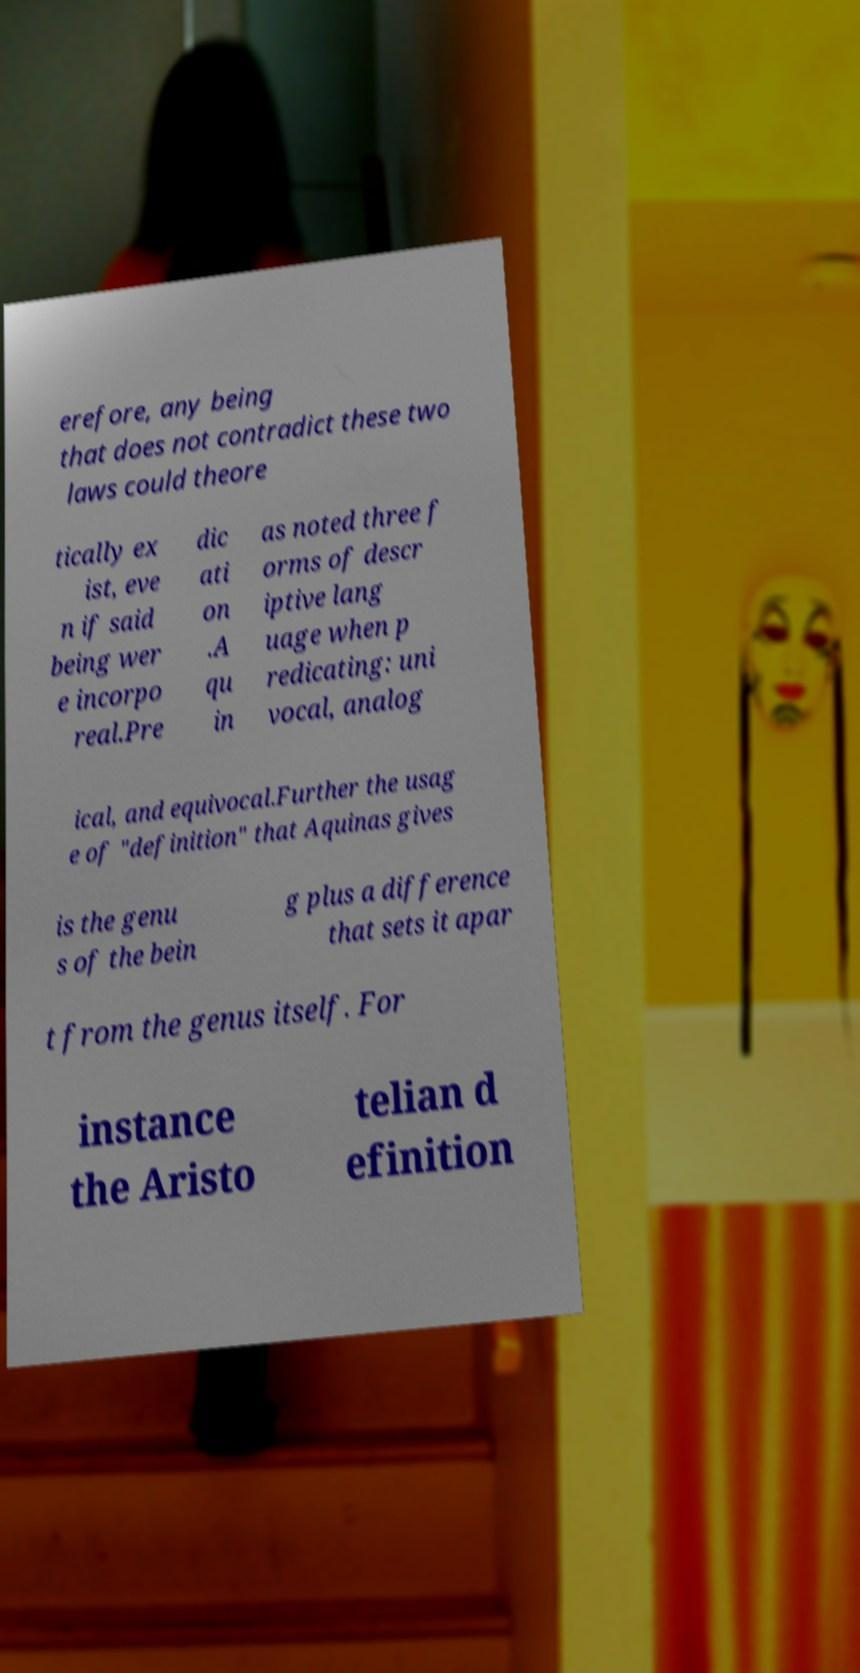Please identify and transcribe the text found in this image. erefore, any being that does not contradict these two laws could theore tically ex ist, eve n if said being wer e incorpo real.Pre dic ati on .A qu in as noted three f orms of descr iptive lang uage when p redicating: uni vocal, analog ical, and equivocal.Further the usag e of "definition" that Aquinas gives is the genu s of the bein g plus a difference that sets it apar t from the genus itself. For instance the Aristo telian d efinition 